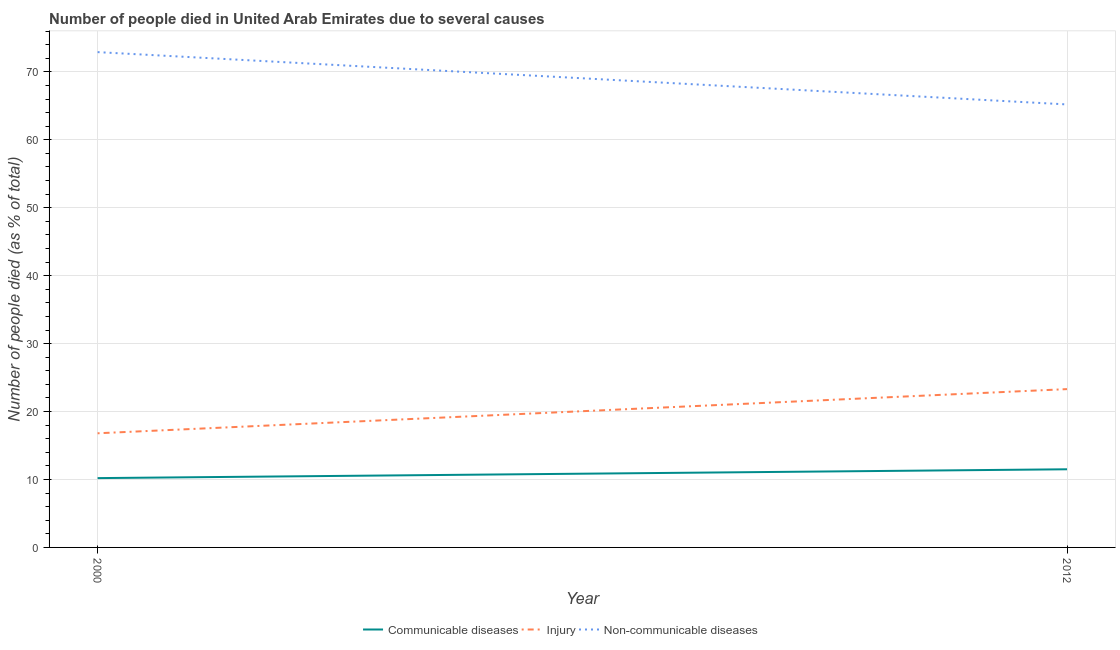Does the line corresponding to number of people who dies of non-communicable diseases intersect with the line corresponding to number of people who died of communicable diseases?
Keep it short and to the point. No. What is the number of people who died of injury in 2012?
Offer a terse response. 23.3. Across all years, what is the minimum number of people who dies of non-communicable diseases?
Make the answer very short. 65.2. What is the total number of people who dies of non-communicable diseases in the graph?
Offer a very short reply. 138.1. What is the difference between the number of people who dies of non-communicable diseases in 2000 and that in 2012?
Make the answer very short. 7.7. What is the difference between the number of people who dies of non-communicable diseases in 2012 and the number of people who died of injury in 2000?
Give a very brief answer. 48.4. What is the average number of people who died of injury per year?
Offer a terse response. 20.05. In the year 2000, what is the difference between the number of people who died of injury and number of people who died of communicable diseases?
Offer a terse response. 6.6. In how many years, is the number of people who died of communicable diseases greater than 38 %?
Give a very brief answer. 0. What is the ratio of the number of people who died of injury in 2000 to that in 2012?
Your response must be concise. 0.72. Is it the case that in every year, the sum of the number of people who died of communicable diseases and number of people who died of injury is greater than the number of people who dies of non-communicable diseases?
Your response must be concise. No. Does the number of people who dies of non-communicable diseases monotonically increase over the years?
Your answer should be very brief. No. Is the number of people who dies of non-communicable diseases strictly greater than the number of people who died of communicable diseases over the years?
Your answer should be very brief. Yes. Is the number of people who dies of non-communicable diseases strictly less than the number of people who died of injury over the years?
Provide a short and direct response. No. Does the graph contain any zero values?
Offer a very short reply. No. Where does the legend appear in the graph?
Make the answer very short. Bottom center. How many legend labels are there?
Your response must be concise. 3. What is the title of the graph?
Ensure brevity in your answer.  Number of people died in United Arab Emirates due to several causes. What is the label or title of the Y-axis?
Keep it short and to the point. Number of people died (as % of total). What is the Number of people died (as % of total) in Communicable diseases in 2000?
Give a very brief answer. 10.2. What is the Number of people died (as % of total) in Injury in 2000?
Offer a very short reply. 16.8. What is the Number of people died (as % of total) in Non-communicable diseases in 2000?
Keep it short and to the point. 72.9. What is the Number of people died (as % of total) of Injury in 2012?
Keep it short and to the point. 23.3. What is the Number of people died (as % of total) in Non-communicable diseases in 2012?
Your answer should be compact. 65.2. Across all years, what is the maximum Number of people died (as % of total) in Communicable diseases?
Your answer should be compact. 11.5. Across all years, what is the maximum Number of people died (as % of total) of Injury?
Provide a succinct answer. 23.3. Across all years, what is the maximum Number of people died (as % of total) in Non-communicable diseases?
Your response must be concise. 72.9. Across all years, what is the minimum Number of people died (as % of total) of Communicable diseases?
Your answer should be very brief. 10.2. Across all years, what is the minimum Number of people died (as % of total) of Injury?
Ensure brevity in your answer.  16.8. Across all years, what is the minimum Number of people died (as % of total) of Non-communicable diseases?
Ensure brevity in your answer.  65.2. What is the total Number of people died (as % of total) of Communicable diseases in the graph?
Provide a short and direct response. 21.7. What is the total Number of people died (as % of total) of Injury in the graph?
Offer a terse response. 40.1. What is the total Number of people died (as % of total) of Non-communicable diseases in the graph?
Make the answer very short. 138.1. What is the difference between the Number of people died (as % of total) of Communicable diseases in 2000 and that in 2012?
Keep it short and to the point. -1.3. What is the difference between the Number of people died (as % of total) in Non-communicable diseases in 2000 and that in 2012?
Provide a succinct answer. 7.7. What is the difference between the Number of people died (as % of total) in Communicable diseases in 2000 and the Number of people died (as % of total) in Injury in 2012?
Your answer should be very brief. -13.1. What is the difference between the Number of people died (as % of total) in Communicable diseases in 2000 and the Number of people died (as % of total) in Non-communicable diseases in 2012?
Offer a very short reply. -55. What is the difference between the Number of people died (as % of total) in Injury in 2000 and the Number of people died (as % of total) in Non-communicable diseases in 2012?
Provide a succinct answer. -48.4. What is the average Number of people died (as % of total) of Communicable diseases per year?
Keep it short and to the point. 10.85. What is the average Number of people died (as % of total) of Injury per year?
Provide a short and direct response. 20.05. What is the average Number of people died (as % of total) in Non-communicable diseases per year?
Provide a succinct answer. 69.05. In the year 2000, what is the difference between the Number of people died (as % of total) of Communicable diseases and Number of people died (as % of total) of Injury?
Give a very brief answer. -6.6. In the year 2000, what is the difference between the Number of people died (as % of total) in Communicable diseases and Number of people died (as % of total) in Non-communicable diseases?
Provide a succinct answer. -62.7. In the year 2000, what is the difference between the Number of people died (as % of total) in Injury and Number of people died (as % of total) in Non-communicable diseases?
Offer a very short reply. -56.1. In the year 2012, what is the difference between the Number of people died (as % of total) of Communicable diseases and Number of people died (as % of total) of Non-communicable diseases?
Your answer should be very brief. -53.7. In the year 2012, what is the difference between the Number of people died (as % of total) of Injury and Number of people died (as % of total) of Non-communicable diseases?
Provide a short and direct response. -41.9. What is the ratio of the Number of people died (as % of total) in Communicable diseases in 2000 to that in 2012?
Give a very brief answer. 0.89. What is the ratio of the Number of people died (as % of total) in Injury in 2000 to that in 2012?
Your answer should be compact. 0.72. What is the ratio of the Number of people died (as % of total) of Non-communicable diseases in 2000 to that in 2012?
Provide a succinct answer. 1.12. What is the difference between the highest and the second highest Number of people died (as % of total) of Injury?
Your answer should be very brief. 6.5. What is the difference between the highest and the second highest Number of people died (as % of total) in Non-communicable diseases?
Your answer should be compact. 7.7. What is the difference between the highest and the lowest Number of people died (as % of total) in Injury?
Keep it short and to the point. 6.5. What is the difference between the highest and the lowest Number of people died (as % of total) in Non-communicable diseases?
Keep it short and to the point. 7.7. 